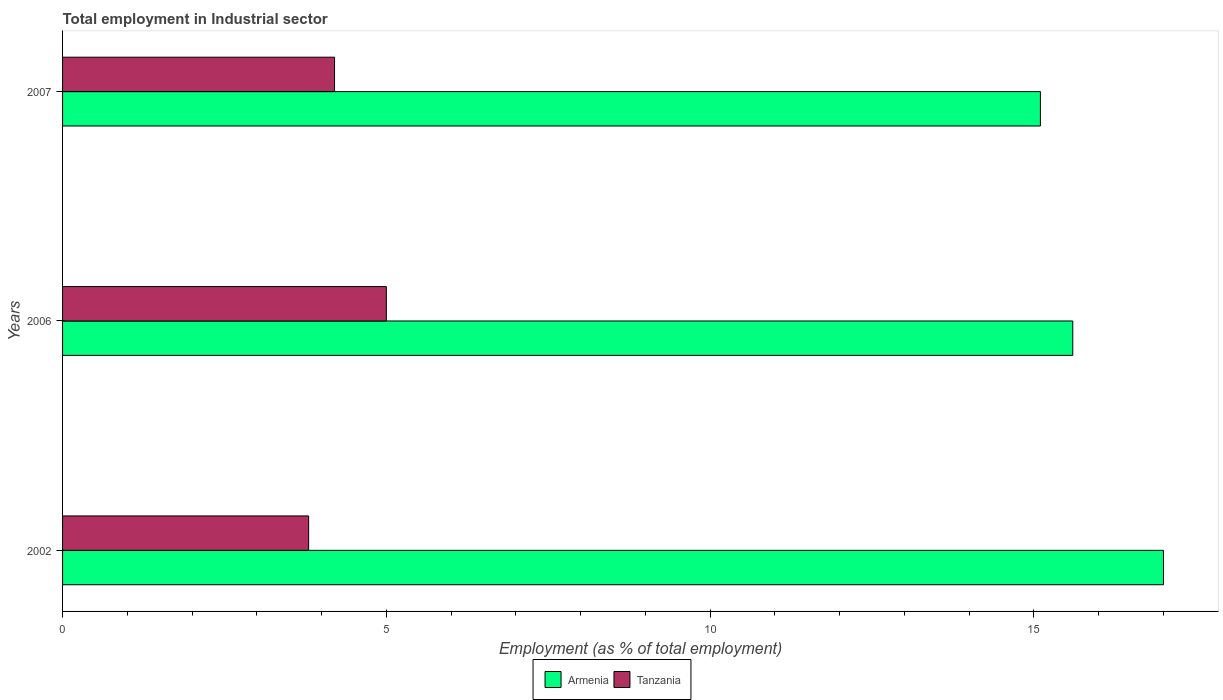In how many cases, is the number of bars for a given year not equal to the number of legend labels?
Offer a very short reply. 0. What is the employment in industrial sector in Armenia in 2007?
Keep it short and to the point. 15.1. Across all years, what is the maximum employment in industrial sector in Armenia?
Ensure brevity in your answer.  17. Across all years, what is the minimum employment in industrial sector in Armenia?
Offer a very short reply. 15.1. In which year was the employment in industrial sector in Tanzania maximum?
Your answer should be very brief. 2006. In which year was the employment in industrial sector in Tanzania minimum?
Provide a short and direct response. 2002. What is the total employment in industrial sector in Tanzania in the graph?
Ensure brevity in your answer.  13. What is the difference between the employment in industrial sector in Armenia in 2002 and that in 2007?
Your answer should be compact. 1.9. What is the difference between the employment in industrial sector in Armenia in 2006 and the employment in industrial sector in Tanzania in 2002?
Offer a terse response. 11.8. What is the average employment in industrial sector in Armenia per year?
Your answer should be compact. 15.9. In the year 2006, what is the difference between the employment in industrial sector in Armenia and employment in industrial sector in Tanzania?
Offer a very short reply. 10.6. In how many years, is the employment in industrial sector in Armenia greater than 3 %?
Provide a short and direct response. 3. What is the ratio of the employment in industrial sector in Armenia in 2002 to that in 2007?
Make the answer very short. 1.13. Is the difference between the employment in industrial sector in Armenia in 2002 and 2007 greater than the difference between the employment in industrial sector in Tanzania in 2002 and 2007?
Your answer should be compact. Yes. What is the difference between the highest and the second highest employment in industrial sector in Armenia?
Your answer should be very brief. 1.4. What is the difference between the highest and the lowest employment in industrial sector in Armenia?
Make the answer very short. 1.9. In how many years, is the employment in industrial sector in Armenia greater than the average employment in industrial sector in Armenia taken over all years?
Ensure brevity in your answer.  1. Is the sum of the employment in industrial sector in Armenia in 2002 and 2006 greater than the maximum employment in industrial sector in Tanzania across all years?
Keep it short and to the point. Yes. What does the 2nd bar from the top in 2006 represents?
Give a very brief answer. Armenia. What does the 1st bar from the bottom in 2007 represents?
Your answer should be compact. Armenia. Are the values on the major ticks of X-axis written in scientific E-notation?
Offer a terse response. No. Does the graph contain any zero values?
Your response must be concise. No. How many legend labels are there?
Give a very brief answer. 2. What is the title of the graph?
Give a very brief answer. Total employment in Industrial sector. Does "Turks and Caicos Islands" appear as one of the legend labels in the graph?
Your answer should be very brief. No. What is the label or title of the X-axis?
Give a very brief answer. Employment (as % of total employment). What is the Employment (as % of total employment) of Armenia in 2002?
Offer a terse response. 17. What is the Employment (as % of total employment) in Tanzania in 2002?
Your response must be concise. 3.8. What is the Employment (as % of total employment) in Armenia in 2006?
Give a very brief answer. 15.6. What is the Employment (as % of total employment) in Tanzania in 2006?
Provide a succinct answer. 5. What is the Employment (as % of total employment) of Armenia in 2007?
Your answer should be very brief. 15.1. What is the Employment (as % of total employment) of Tanzania in 2007?
Ensure brevity in your answer.  4.2. Across all years, what is the maximum Employment (as % of total employment) in Tanzania?
Your response must be concise. 5. Across all years, what is the minimum Employment (as % of total employment) of Armenia?
Your answer should be very brief. 15.1. Across all years, what is the minimum Employment (as % of total employment) in Tanzania?
Your answer should be very brief. 3.8. What is the total Employment (as % of total employment) in Armenia in the graph?
Ensure brevity in your answer.  47.7. What is the total Employment (as % of total employment) of Tanzania in the graph?
Provide a succinct answer. 13. What is the difference between the Employment (as % of total employment) of Armenia in 2002 and that in 2006?
Your answer should be very brief. 1.4. What is the difference between the Employment (as % of total employment) of Tanzania in 2002 and that in 2006?
Provide a short and direct response. -1.2. What is the difference between the Employment (as % of total employment) in Armenia in 2002 and that in 2007?
Offer a very short reply. 1.9. What is the difference between the Employment (as % of total employment) of Armenia in 2006 and that in 2007?
Ensure brevity in your answer.  0.5. What is the difference between the Employment (as % of total employment) of Armenia in 2002 and the Employment (as % of total employment) of Tanzania in 2007?
Provide a short and direct response. 12.8. What is the average Employment (as % of total employment) in Tanzania per year?
Your response must be concise. 4.33. In the year 2002, what is the difference between the Employment (as % of total employment) in Armenia and Employment (as % of total employment) in Tanzania?
Keep it short and to the point. 13.2. In the year 2006, what is the difference between the Employment (as % of total employment) of Armenia and Employment (as % of total employment) of Tanzania?
Your response must be concise. 10.6. In the year 2007, what is the difference between the Employment (as % of total employment) of Armenia and Employment (as % of total employment) of Tanzania?
Ensure brevity in your answer.  10.9. What is the ratio of the Employment (as % of total employment) of Armenia in 2002 to that in 2006?
Your answer should be very brief. 1.09. What is the ratio of the Employment (as % of total employment) of Tanzania in 2002 to that in 2006?
Provide a short and direct response. 0.76. What is the ratio of the Employment (as % of total employment) in Armenia in 2002 to that in 2007?
Offer a terse response. 1.13. What is the ratio of the Employment (as % of total employment) in Tanzania in 2002 to that in 2007?
Provide a short and direct response. 0.9. What is the ratio of the Employment (as % of total employment) of Armenia in 2006 to that in 2007?
Your answer should be very brief. 1.03. What is the ratio of the Employment (as % of total employment) in Tanzania in 2006 to that in 2007?
Ensure brevity in your answer.  1.19. What is the difference between the highest and the lowest Employment (as % of total employment) of Armenia?
Your answer should be compact. 1.9. What is the difference between the highest and the lowest Employment (as % of total employment) of Tanzania?
Your answer should be very brief. 1.2. 